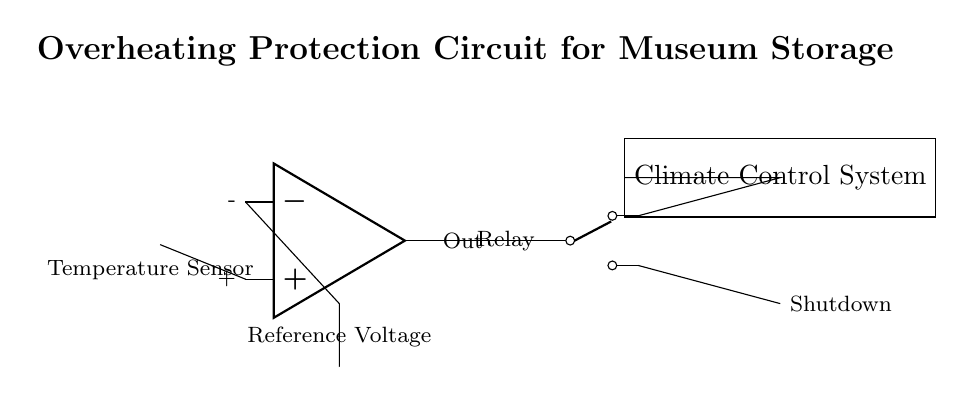What component is used to measure temperature? The component used to measure temperature is a temperature sensor, specifically labeled as a thermistor in the circuit.
Answer: Temperature Sensor What type of relay is shown in the circuit? The relay shown in the circuit is a Single Pole Double Throw (SPDT) relay, which is indicated by the specific symbol used in the diagram.
Answer: SPDT How does the output of the comparator affect the relay? The output of the comparator controls the relay; if the temperature sensor detects an overheating condition, the output signal will activate the relay, thus controlling the climate control system.
Answer: It activates the relay What is the purpose of the reference voltage in this circuit? The reference voltage serves as a benchmark for the comparator to determine whether the temperature exceeds a specific threshold; this helps in deciding if the relay should be activated or not.
Answer: To set a temperature threshold What action is taken when overheating is detected? When overheating is detected, the relay will be activated, thereby shutting down the climate control system to prevent damage.
Answer: Shutdown How are the temperature sensor and comparator connected? The temperature sensor is connected to the non-inverting input of the comparator, signaling it with the temperature data, which is essential for the comparator's operation.
Answer: The sensor connects to the non-inverting input 